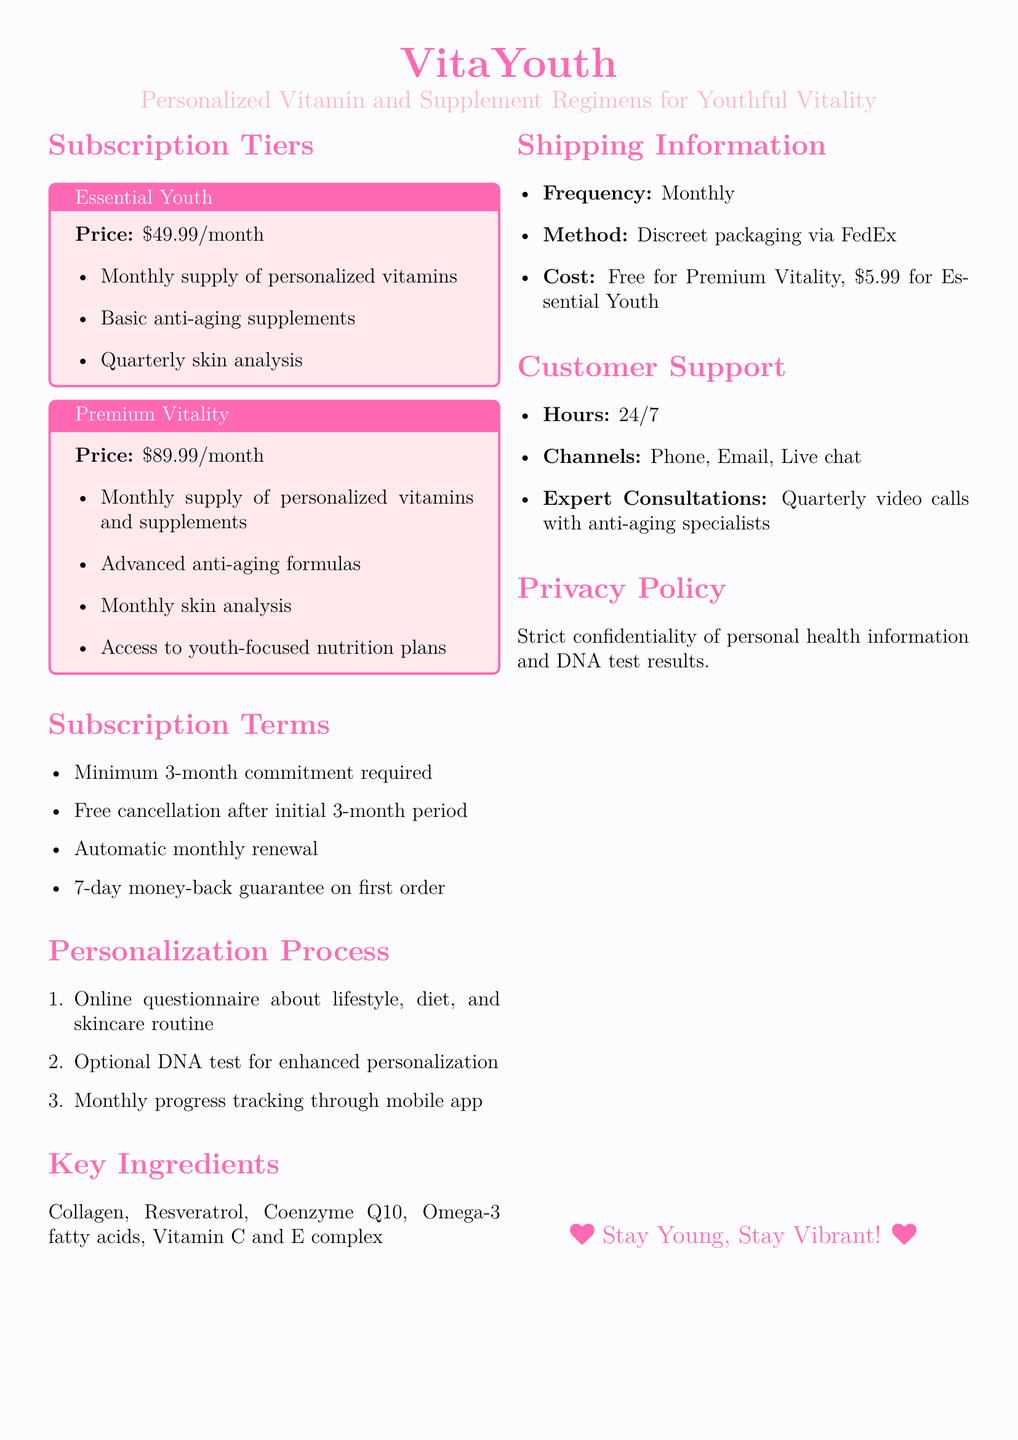What is the monthly cost of the Premium Vitality plan? The Premium Vitality plan is listed with a price of $89.99 per month.
Answer: $89.99 What is included in the Essential Youth subscription? The Essential Youth subscription includes personalized vitamins, basic anti-aging supplements, and a quarterly skin analysis.
Answer: Monthly supply of personalized vitamins, Basic anti-aging supplements, Quarterly skin analysis What is the minimum commitment period for subscriptions? The document states that a minimum commitment of 3 months is required for subscriptions.
Answer: 3-month What is the shipping cost for the Essential Youth plan? The document specifies that the shipping cost for the Essential Youth plan is $5.99.
Answer: $5.99 How often are skin analyses conducted in the Premium Vitality plan? The Premium Vitality plan includes a monthly skin analysis as part of the subscription.
Answer: Monthly What is the frequency of the subscription shipments? The document mentions that the subscription shipments occur monthly.
Answer: Monthly What type of test is optional for enhanced personalization? The document states that an optional DNA test is available for enhanced personalization.
Answer: DNA test What is the customer support availability? The customer support hours are stated to be 24/7.
Answer: 24/7 What type of packaging is used for shipping? The document indicates that the method involves discreet packaging via FedEx.
Answer: Discreet packaging via FedEx 